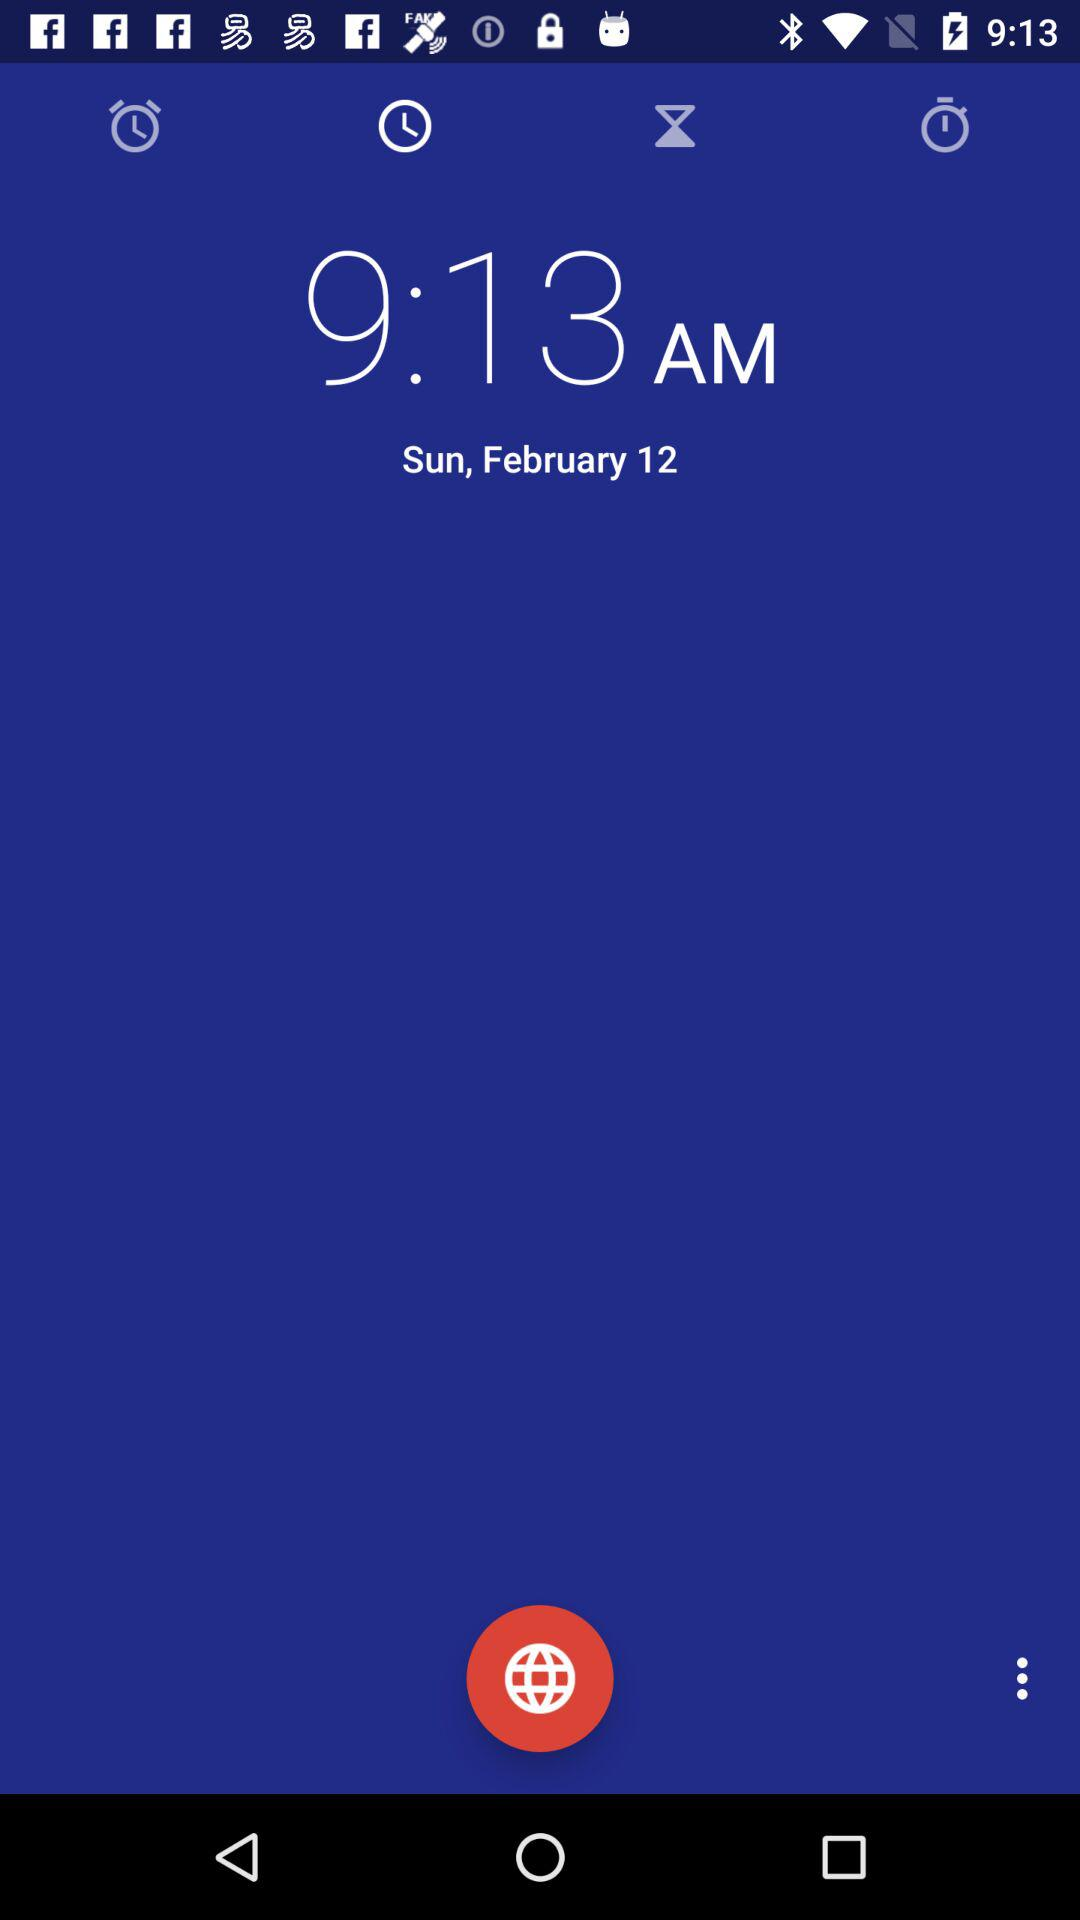What is the time? The time is 9:13 AM. 